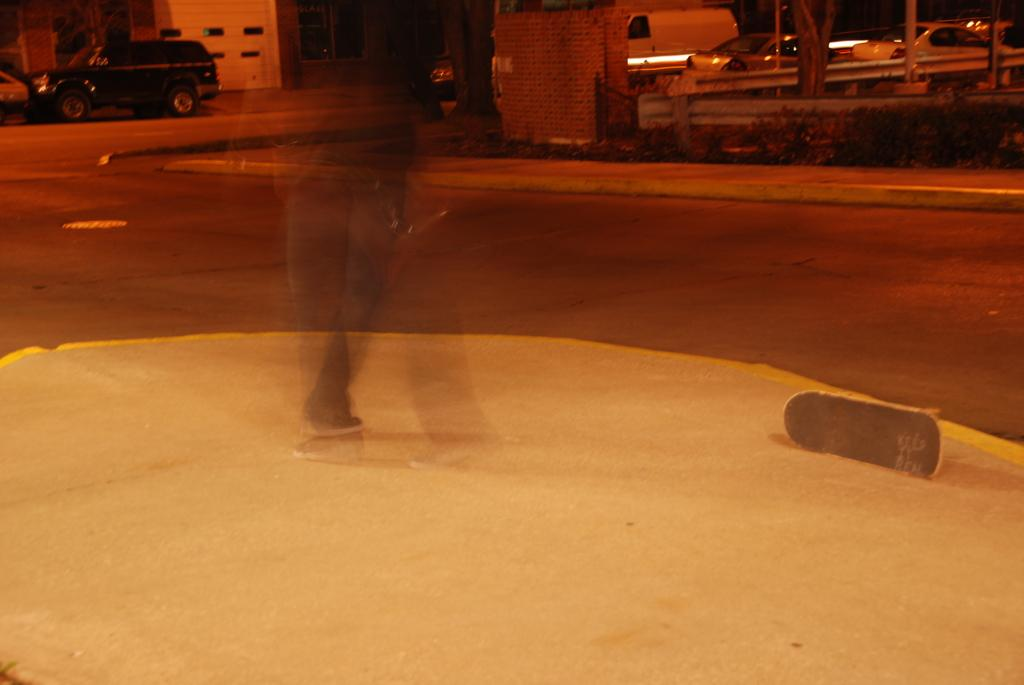What is the main subject of the image? There is a blurry image of a person. What object is near the person? There is a skateboard beside the person. What can be seen in the background of the image? There are vehicles in the background of the image. What type of butter is being used by the person in the image? There is no butter present in the image. Is the person wearing a ring in the image? The image is blurry, and it is difficult to determine if the person is wearing a ring or not. 